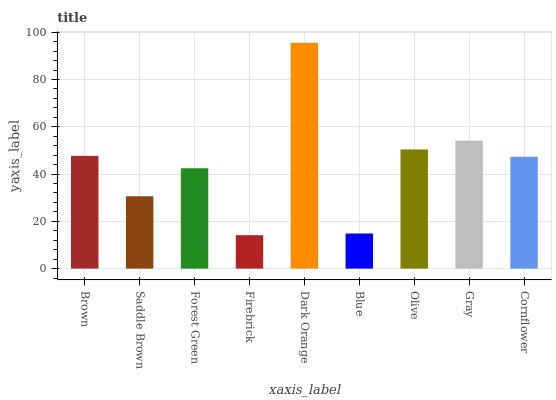Is Saddle Brown the minimum?
Answer yes or no. No. Is Saddle Brown the maximum?
Answer yes or no. No. Is Brown greater than Saddle Brown?
Answer yes or no. Yes. Is Saddle Brown less than Brown?
Answer yes or no. Yes. Is Saddle Brown greater than Brown?
Answer yes or no. No. Is Brown less than Saddle Brown?
Answer yes or no. No. Is Cornflower the high median?
Answer yes or no. Yes. Is Cornflower the low median?
Answer yes or no. Yes. Is Gray the high median?
Answer yes or no. No. Is Dark Orange the low median?
Answer yes or no. No. 